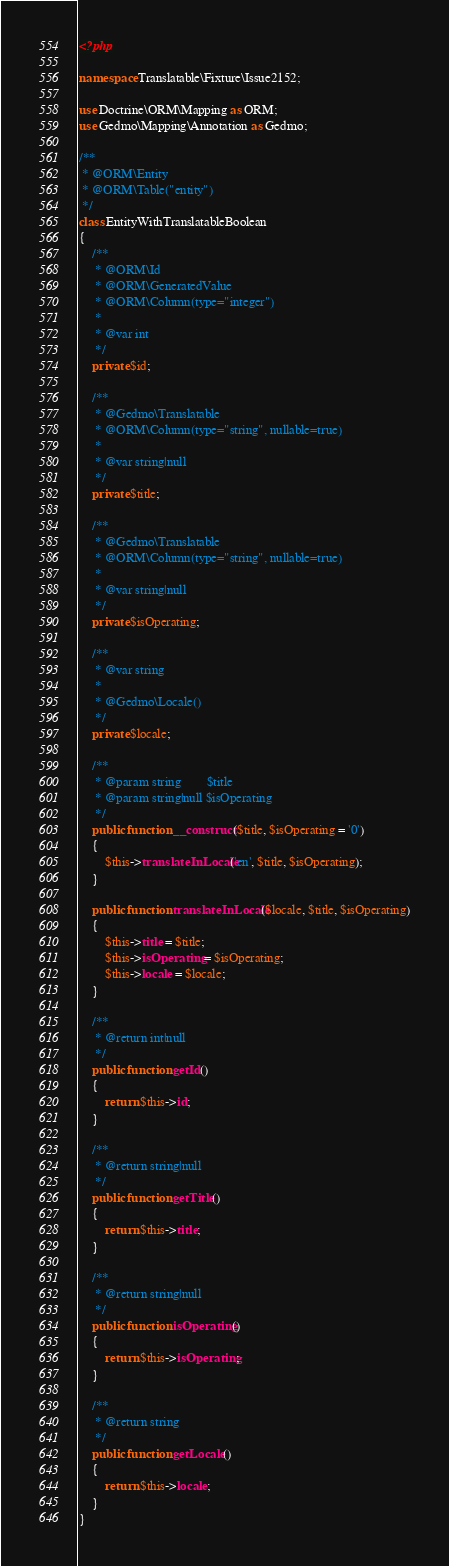Convert code to text. <code><loc_0><loc_0><loc_500><loc_500><_PHP_><?php

namespace Translatable\Fixture\Issue2152;

use Doctrine\ORM\Mapping as ORM;
use Gedmo\Mapping\Annotation as Gedmo;

/**
 * @ORM\Entity
 * @ORM\Table("entity")
 */
class EntityWithTranslatableBoolean
{
    /**
     * @ORM\Id
     * @ORM\GeneratedValue
     * @ORM\Column(type="integer")
     *
     * @var int
     */
    private $id;

    /**
     * @Gedmo\Translatable
     * @ORM\Column(type="string", nullable=true)
     *
     * @var string|null
     */
    private $title;

    /**
     * @Gedmo\Translatable
     * @ORM\Column(type="string", nullable=true)
     *
     * @var string|null
     */
    private $isOperating;

    /**
     * @var string
     *
     * @Gedmo\Locale()
     */
    private $locale;

    /**
     * @param string        $title
     * @param string|null $isOperating
     */
    public function __construct($title, $isOperating = '0')
    {
        $this->translateInLocale('en', $title, $isOperating);
    }

    public function translateInLocale($locale, $title, $isOperating)
    {
        $this->title = $title;
        $this->isOperating = $isOperating;
        $this->locale = $locale;
    }

    /**
     * @return int|null
     */
    public function getId()
    {
        return $this->id;
    }

    /**
     * @return string|null
     */
    public function getTitle()
    {
        return $this->title;
    }

    /**
     * @return string|null
     */
    public function isOperating()
    {
        return $this->isOperating;
    }

    /**
     * @return string
     */
    public function getLocale()
    {
        return $this->locale;
    }
}
</code> 